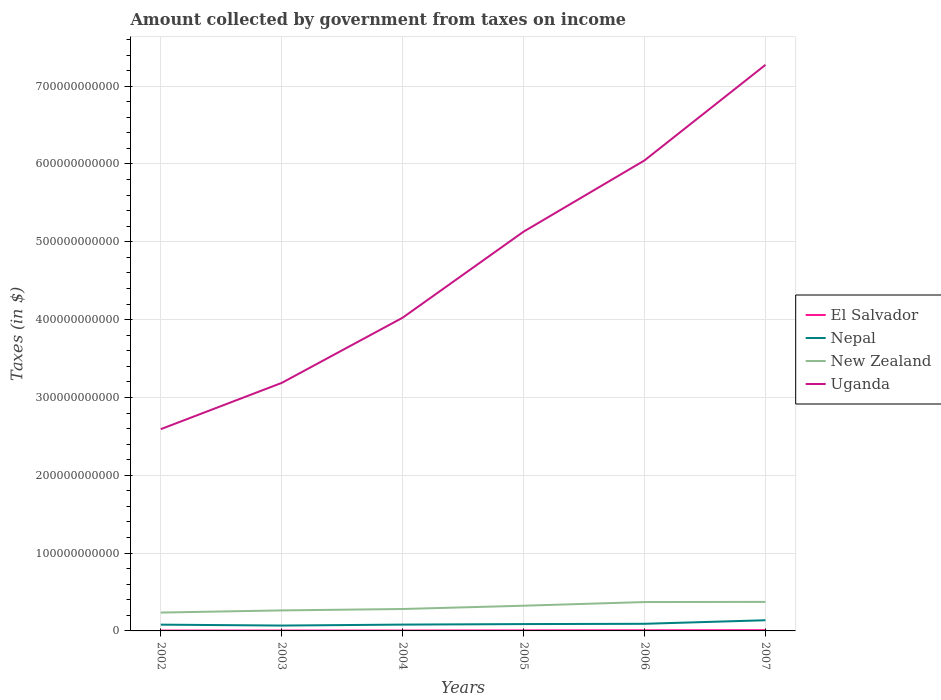Is the number of lines equal to the number of legend labels?
Offer a very short reply. Yes. Across all years, what is the maximum amount collected by government from taxes on income in Uganda?
Make the answer very short. 2.59e+11. In which year was the amount collected by government from taxes on income in Nepal maximum?
Offer a very short reply. 2003. What is the total amount collected by government from taxes on income in New Zealand in the graph?
Give a very brief answer. -9.16e+09. What is the difference between the highest and the second highest amount collected by government from taxes on income in El Salvador?
Ensure brevity in your answer.  4.94e+08. What is the difference between two consecutive major ticks on the Y-axis?
Give a very brief answer. 1.00e+11. Does the graph contain any zero values?
Offer a terse response. No. Where does the legend appear in the graph?
Offer a very short reply. Center right. What is the title of the graph?
Offer a terse response. Amount collected by government from taxes on income. Does "Papua New Guinea" appear as one of the legend labels in the graph?
Make the answer very short. No. What is the label or title of the X-axis?
Give a very brief answer. Years. What is the label or title of the Y-axis?
Your answer should be very brief. Taxes (in $). What is the Taxes (in $) in El Salvador in 2002?
Give a very brief answer. 4.71e+08. What is the Taxes (in $) in Nepal in 2002?
Give a very brief answer. 8.07e+09. What is the Taxes (in $) in New Zealand in 2002?
Your answer should be very brief. 2.36e+1. What is the Taxes (in $) in Uganda in 2002?
Offer a very short reply. 2.59e+11. What is the Taxes (in $) in El Salvador in 2003?
Keep it short and to the point. 4.98e+08. What is the Taxes (in $) in Nepal in 2003?
Offer a very short reply. 6.88e+09. What is the Taxes (in $) in New Zealand in 2003?
Offer a very short reply. 2.64e+1. What is the Taxes (in $) in Uganda in 2003?
Give a very brief answer. 3.19e+11. What is the Taxes (in $) of El Salvador in 2004?
Provide a short and direct response. 5.25e+08. What is the Taxes (in $) of Nepal in 2004?
Make the answer very short. 8.12e+09. What is the Taxes (in $) of New Zealand in 2004?
Provide a succinct answer. 2.82e+1. What is the Taxes (in $) of Uganda in 2004?
Offer a very short reply. 4.02e+11. What is the Taxes (in $) of El Salvador in 2005?
Your answer should be very brief. 6.63e+08. What is the Taxes (in $) in Nepal in 2005?
Your answer should be very brief. 8.79e+09. What is the Taxes (in $) of New Zealand in 2005?
Ensure brevity in your answer.  3.24e+1. What is the Taxes (in $) in Uganda in 2005?
Offer a terse response. 5.13e+11. What is the Taxes (in $) of El Salvador in 2006?
Your answer should be very brief. 8.16e+08. What is the Taxes (in $) in Nepal in 2006?
Make the answer very short. 9.16e+09. What is the Taxes (in $) of New Zealand in 2006?
Provide a short and direct response. 3.71e+1. What is the Taxes (in $) in Uganda in 2006?
Provide a succinct answer. 6.05e+11. What is the Taxes (in $) in El Salvador in 2007?
Your answer should be very brief. 9.65e+08. What is the Taxes (in $) in Nepal in 2007?
Your answer should be very brief. 1.37e+1. What is the Taxes (in $) of New Zealand in 2007?
Your answer should be very brief. 3.73e+1. What is the Taxes (in $) in Uganda in 2007?
Keep it short and to the point. 7.27e+11. Across all years, what is the maximum Taxes (in $) of El Salvador?
Offer a terse response. 9.65e+08. Across all years, what is the maximum Taxes (in $) in Nepal?
Give a very brief answer. 1.37e+1. Across all years, what is the maximum Taxes (in $) of New Zealand?
Provide a short and direct response. 3.73e+1. Across all years, what is the maximum Taxes (in $) in Uganda?
Provide a succinct answer. 7.27e+11. Across all years, what is the minimum Taxes (in $) of El Salvador?
Ensure brevity in your answer.  4.71e+08. Across all years, what is the minimum Taxes (in $) in Nepal?
Provide a succinct answer. 6.88e+09. Across all years, what is the minimum Taxes (in $) of New Zealand?
Keep it short and to the point. 2.36e+1. Across all years, what is the minimum Taxes (in $) in Uganda?
Ensure brevity in your answer.  2.59e+11. What is the total Taxes (in $) of El Salvador in the graph?
Your response must be concise. 3.94e+09. What is the total Taxes (in $) of Nepal in the graph?
Offer a terse response. 5.47e+1. What is the total Taxes (in $) of New Zealand in the graph?
Offer a very short reply. 1.85e+11. What is the total Taxes (in $) of Uganda in the graph?
Make the answer very short. 2.83e+12. What is the difference between the Taxes (in $) in El Salvador in 2002 and that in 2003?
Your answer should be very brief. -2.67e+07. What is the difference between the Taxes (in $) of Nepal in 2002 and that in 2003?
Ensure brevity in your answer.  1.19e+09. What is the difference between the Taxes (in $) of New Zealand in 2002 and that in 2003?
Offer a terse response. -2.76e+09. What is the difference between the Taxes (in $) in Uganda in 2002 and that in 2003?
Offer a very short reply. -5.94e+1. What is the difference between the Taxes (in $) of El Salvador in 2002 and that in 2004?
Your answer should be very brief. -5.35e+07. What is the difference between the Taxes (in $) of Nepal in 2002 and that in 2004?
Give a very brief answer. -5.53e+07. What is the difference between the Taxes (in $) in New Zealand in 2002 and that in 2004?
Give a very brief answer. -4.56e+09. What is the difference between the Taxes (in $) of Uganda in 2002 and that in 2004?
Your answer should be very brief. -1.43e+11. What is the difference between the Taxes (in $) in El Salvador in 2002 and that in 2005?
Keep it short and to the point. -1.91e+08. What is the difference between the Taxes (in $) in Nepal in 2002 and that in 2005?
Your answer should be compact. -7.22e+08. What is the difference between the Taxes (in $) in New Zealand in 2002 and that in 2005?
Your answer should be compact. -8.78e+09. What is the difference between the Taxes (in $) in Uganda in 2002 and that in 2005?
Your answer should be compact. -2.54e+11. What is the difference between the Taxes (in $) of El Salvador in 2002 and that in 2006?
Offer a terse response. -3.44e+08. What is the difference between the Taxes (in $) in Nepal in 2002 and that in 2006?
Provide a short and direct response. -1.09e+09. What is the difference between the Taxes (in $) of New Zealand in 2002 and that in 2006?
Ensure brevity in your answer.  -1.35e+1. What is the difference between the Taxes (in $) in Uganda in 2002 and that in 2006?
Keep it short and to the point. -3.45e+11. What is the difference between the Taxes (in $) of El Salvador in 2002 and that in 2007?
Provide a short and direct response. -4.94e+08. What is the difference between the Taxes (in $) in Nepal in 2002 and that in 2007?
Offer a terse response. -5.66e+09. What is the difference between the Taxes (in $) of New Zealand in 2002 and that in 2007?
Ensure brevity in your answer.  -1.37e+1. What is the difference between the Taxes (in $) in Uganda in 2002 and that in 2007?
Make the answer very short. -4.68e+11. What is the difference between the Taxes (in $) of El Salvador in 2003 and that in 2004?
Your answer should be compact. -2.68e+07. What is the difference between the Taxes (in $) of Nepal in 2003 and that in 2004?
Make the answer very short. -1.24e+09. What is the difference between the Taxes (in $) in New Zealand in 2003 and that in 2004?
Provide a succinct answer. -1.80e+09. What is the difference between the Taxes (in $) of Uganda in 2003 and that in 2004?
Ensure brevity in your answer.  -8.38e+1. What is the difference between the Taxes (in $) of El Salvador in 2003 and that in 2005?
Your answer should be very brief. -1.65e+08. What is the difference between the Taxes (in $) in Nepal in 2003 and that in 2005?
Your answer should be very brief. -1.91e+09. What is the difference between the Taxes (in $) of New Zealand in 2003 and that in 2005?
Offer a very short reply. -6.02e+09. What is the difference between the Taxes (in $) in Uganda in 2003 and that in 2005?
Keep it short and to the point. -1.94e+11. What is the difference between the Taxes (in $) of El Salvador in 2003 and that in 2006?
Keep it short and to the point. -3.18e+08. What is the difference between the Taxes (in $) in Nepal in 2003 and that in 2006?
Provide a succinct answer. -2.28e+09. What is the difference between the Taxes (in $) of New Zealand in 2003 and that in 2006?
Ensure brevity in your answer.  -1.07e+1. What is the difference between the Taxes (in $) of Uganda in 2003 and that in 2006?
Provide a short and direct response. -2.86e+11. What is the difference between the Taxes (in $) of El Salvador in 2003 and that in 2007?
Offer a very short reply. -4.67e+08. What is the difference between the Taxes (in $) of Nepal in 2003 and that in 2007?
Offer a terse response. -6.84e+09. What is the difference between the Taxes (in $) in New Zealand in 2003 and that in 2007?
Keep it short and to the point. -1.10e+1. What is the difference between the Taxes (in $) in Uganda in 2003 and that in 2007?
Make the answer very short. -4.09e+11. What is the difference between the Taxes (in $) of El Salvador in 2004 and that in 2005?
Ensure brevity in your answer.  -1.38e+08. What is the difference between the Taxes (in $) of Nepal in 2004 and that in 2005?
Your answer should be compact. -6.67e+08. What is the difference between the Taxes (in $) of New Zealand in 2004 and that in 2005?
Provide a succinct answer. -4.22e+09. What is the difference between the Taxes (in $) of Uganda in 2004 and that in 2005?
Give a very brief answer. -1.11e+11. What is the difference between the Taxes (in $) of El Salvador in 2004 and that in 2006?
Keep it short and to the point. -2.91e+08. What is the difference between the Taxes (in $) in Nepal in 2004 and that in 2006?
Make the answer very short. -1.04e+09. What is the difference between the Taxes (in $) of New Zealand in 2004 and that in 2006?
Your answer should be very brief. -8.94e+09. What is the difference between the Taxes (in $) of Uganda in 2004 and that in 2006?
Your response must be concise. -2.02e+11. What is the difference between the Taxes (in $) in El Salvador in 2004 and that in 2007?
Make the answer very short. -4.40e+08. What is the difference between the Taxes (in $) of Nepal in 2004 and that in 2007?
Make the answer very short. -5.60e+09. What is the difference between the Taxes (in $) of New Zealand in 2004 and that in 2007?
Offer a very short reply. -9.16e+09. What is the difference between the Taxes (in $) of Uganda in 2004 and that in 2007?
Keep it short and to the point. -3.25e+11. What is the difference between the Taxes (in $) of El Salvador in 2005 and that in 2006?
Your response must be concise. -1.53e+08. What is the difference between the Taxes (in $) of Nepal in 2005 and that in 2006?
Keep it short and to the point. -3.72e+08. What is the difference between the Taxes (in $) of New Zealand in 2005 and that in 2006?
Your response must be concise. -4.72e+09. What is the difference between the Taxes (in $) in Uganda in 2005 and that in 2006?
Your answer should be very brief. -9.16e+1. What is the difference between the Taxes (in $) of El Salvador in 2005 and that in 2007?
Your answer should be compact. -3.02e+08. What is the difference between the Taxes (in $) of Nepal in 2005 and that in 2007?
Your response must be concise. -4.93e+09. What is the difference between the Taxes (in $) of New Zealand in 2005 and that in 2007?
Give a very brief answer. -4.94e+09. What is the difference between the Taxes (in $) in Uganda in 2005 and that in 2007?
Ensure brevity in your answer.  -2.14e+11. What is the difference between the Taxes (in $) in El Salvador in 2006 and that in 2007?
Keep it short and to the point. -1.49e+08. What is the difference between the Taxes (in $) in Nepal in 2006 and that in 2007?
Offer a terse response. -4.56e+09. What is the difference between the Taxes (in $) in New Zealand in 2006 and that in 2007?
Keep it short and to the point. -2.25e+08. What is the difference between the Taxes (in $) of Uganda in 2006 and that in 2007?
Your response must be concise. -1.23e+11. What is the difference between the Taxes (in $) of El Salvador in 2002 and the Taxes (in $) of Nepal in 2003?
Keep it short and to the point. -6.41e+09. What is the difference between the Taxes (in $) in El Salvador in 2002 and the Taxes (in $) in New Zealand in 2003?
Provide a short and direct response. -2.59e+1. What is the difference between the Taxes (in $) in El Salvador in 2002 and the Taxes (in $) in Uganda in 2003?
Provide a short and direct response. -3.18e+11. What is the difference between the Taxes (in $) in Nepal in 2002 and the Taxes (in $) in New Zealand in 2003?
Your answer should be compact. -1.83e+1. What is the difference between the Taxes (in $) in Nepal in 2002 and the Taxes (in $) in Uganda in 2003?
Give a very brief answer. -3.11e+11. What is the difference between the Taxes (in $) of New Zealand in 2002 and the Taxes (in $) of Uganda in 2003?
Offer a terse response. -2.95e+11. What is the difference between the Taxes (in $) in El Salvador in 2002 and the Taxes (in $) in Nepal in 2004?
Offer a very short reply. -7.65e+09. What is the difference between the Taxes (in $) of El Salvador in 2002 and the Taxes (in $) of New Zealand in 2004?
Offer a terse response. -2.77e+1. What is the difference between the Taxes (in $) in El Salvador in 2002 and the Taxes (in $) in Uganda in 2004?
Keep it short and to the point. -4.02e+11. What is the difference between the Taxes (in $) in Nepal in 2002 and the Taxes (in $) in New Zealand in 2004?
Provide a short and direct response. -2.01e+1. What is the difference between the Taxes (in $) of Nepal in 2002 and the Taxes (in $) of Uganda in 2004?
Offer a very short reply. -3.94e+11. What is the difference between the Taxes (in $) in New Zealand in 2002 and the Taxes (in $) in Uganda in 2004?
Your answer should be very brief. -3.79e+11. What is the difference between the Taxes (in $) of El Salvador in 2002 and the Taxes (in $) of Nepal in 2005?
Your answer should be very brief. -8.32e+09. What is the difference between the Taxes (in $) in El Salvador in 2002 and the Taxes (in $) in New Zealand in 2005?
Ensure brevity in your answer.  -3.19e+1. What is the difference between the Taxes (in $) in El Salvador in 2002 and the Taxes (in $) in Uganda in 2005?
Keep it short and to the point. -5.13e+11. What is the difference between the Taxes (in $) of Nepal in 2002 and the Taxes (in $) of New Zealand in 2005?
Your response must be concise. -2.43e+1. What is the difference between the Taxes (in $) in Nepal in 2002 and the Taxes (in $) in Uganda in 2005?
Ensure brevity in your answer.  -5.05e+11. What is the difference between the Taxes (in $) of New Zealand in 2002 and the Taxes (in $) of Uganda in 2005?
Your response must be concise. -4.89e+11. What is the difference between the Taxes (in $) of El Salvador in 2002 and the Taxes (in $) of Nepal in 2006?
Your response must be concise. -8.69e+09. What is the difference between the Taxes (in $) in El Salvador in 2002 and the Taxes (in $) in New Zealand in 2006?
Keep it short and to the point. -3.66e+1. What is the difference between the Taxes (in $) of El Salvador in 2002 and the Taxes (in $) of Uganda in 2006?
Your answer should be compact. -6.04e+11. What is the difference between the Taxes (in $) in Nepal in 2002 and the Taxes (in $) in New Zealand in 2006?
Your response must be concise. -2.90e+1. What is the difference between the Taxes (in $) of Nepal in 2002 and the Taxes (in $) of Uganda in 2006?
Offer a very short reply. -5.97e+11. What is the difference between the Taxes (in $) of New Zealand in 2002 and the Taxes (in $) of Uganda in 2006?
Provide a succinct answer. -5.81e+11. What is the difference between the Taxes (in $) in El Salvador in 2002 and the Taxes (in $) in Nepal in 2007?
Ensure brevity in your answer.  -1.33e+1. What is the difference between the Taxes (in $) of El Salvador in 2002 and the Taxes (in $) of New Zealand in 2007?
Your answer should be very brief. -3.68e+1. What is the difference between the Taxes (in $) of El Salvador in 2002 and the Taxes (in $) of Uganda in 2007?
Keep it short and to the point. -7.27e+11. What is the difference between the Taxes (in $) of Nepal in 2002 and the Taxes (in $) of New Zealand in 2007?
Provide a succinct answer. -2.93e+1. What is the difference between the Taxes (in $) in Nepal in 2002 and the Taxes (in $) in Uganda in 2007?
Your answer should be compact. -7.19e+11. What is the difference between the Taxes (in $) in New Zealand in 2002 and the Taxes (in $) in Uganda in 2007?
Your answer should be very brief. -7.04e+11. What is the difference between the Taxes (in $) in El Salvador in 2003 and the Taxes (in $) in Nepal in 2004?
Give a very brief answer. -7.63e+09. What is the difference between the Taxes (in $) of El Salvador in 2003 and the Taxes (in $) of New Zealand in 2004?
Provide a short and direct response. -2.77e+1. What is the difference between the Taxes (in $) in El Salvador in 2003 and the Taxes (in $) in Uganda in 2004?
Offer a terse response. -4.02e+11. What is the difference between the Taxes (in $) in Nepal in 2003 and the Taxes (in $) in New Zealand in 2004?
Offer a very short reply. -2.13e+1. What is the difference between the Taxes (in $) in Nepal in 2003 and the Taxes (in $) in Uganda in 2004?
Your answer should be very brief. -3.96e+11. What is the difference between the Taxes (in $) in New Zealand in 2003 and the Taxes (in $) in Uganda in 2004?
Your answer should be compact. -3.76e+11. What is the difference between the Taxes (in $) in El Salvador in 2003 and the Taxes (in $) in Nepal in 2005?
Make the answer very short. -8.29e+09. What is the difference between the Taxes (in $) in El Salvador in 2003 and the Taxes (in $) in New Zealand in 2005?
Ensure brevity in your answer.  -3.19e+1. What is the difference between the Taxes (in $) in El Salvador in 2003 and the Taxes (in $) in Uganda in 2005?
Provide a succinct answer. -5.13e+11. What is the difference between the Taxes (in $) in Nepal in 2003 and the Taxes (in $) in New Zealand in 2005?
Ensure brevity in your answer.  -2.55e+1. What is the difference between the Taxes (in $) in Nepal in 2003 and the Taxes (in $) in Uganda in 2005?
Your response must be concise. -5.06e+11. What is the difference between the Taxes (in $) in New Zealand in 2003 and the Taxes (in $) in Uganda in 2005?
Give a very brief answer. -4.87e+11. What is the difference between the Taxes (in $) in El Salvador in 2003 and the Taxes (in $) in Nepal in 2006?
Offer a very short reply. -8.66e+09. What is the difference between the Taxes (in $) of El Salvador in 2003 and the Taxes (in $) of New Zealand in 2006?
Your response must be concise. -3.66e+1. What is the difference between the Taxes (in $) of El Salvador in 2003 and the Taxes (in $) of Uganda in 2006?
Offer a very short reply. -6.04e+11. What is the difference between the Taxes (in $) in Nepal in 2003 and the Taxes (in $) in New Zealand in 2006?
Offer a terse response. -3.02e+1. What is the difference between the Taxes (in $) in Nepal in 2003 and the Taxes (in $) in Uganda in 2006?
Provide a succinct answer. -5.98e+11. What is the difference between the Taxes (in $) in New Zealand in 2003 and the Taxes (in $) in Uganda in 2006?
Offer a terse response. -5.78e+11. What is the difference between the Taxes (in $) of El Salvador in 2003 and the Taxes (in $) of Nepal in 2007?
Your answer should be very brief. -1.32e+1. What is the difference between the Taxes (in $) in El Salvador in 2003 and the Taxes (in $) in New Zealand in 2007?
Provide a short and direct response. -3.68e+1. What is the difference between the Taxes (in $) in El Salvador in 2003 and the Taxes (in $) in Uganda in 2007?
Your answer should be compact. -7.27e+11. What is the difference between the Taxes (in $) in Nepal in 2003 and the Taxes (in $) in New Zealand in 2007?
Offer a very short reply. -3.04e+1. What is the difference between the Taxes (in $) in Nepal in 2003 and the Taxes (in $) in Uganda in 2007?
Offer a terse response. -7.21e+11. What is the difference between the Taxes (in $) of New Zealand in 2003 and the Taxes (in $) of Uganda in 2007?
Give a very brief answer. -7.01e+11. What is the difference between the Taxes (in $) in El Salvador in 2004 and the Taxes (in $) in Nepal in 2005?
Make the answer very short. -8.27e+09. What is the difference between the Taxes (in $) of El Salvador in 2004 and the Taxes (in $) of New Zealand in 2005?
Ensure brevity in your answer.  -3.19e+1. What is the difference between the Taxes (in $) in El Salvador in 2004 and the Taxes (in $) in Uganda in 2005?
Give a very brief answer. -5.13e+11. What is the difference between the Taxes (in $) of Nepal in 2004 and the Taxes (in $) of New Zealand in 2005?
Keep it short and to the point. -2.43e+1. What is the difference between the Taxes (in $) in Nepal in 2004 and the Taxes (in $) in Uganda in 2005?
Your answer should be compact. -5.05e+11. What is the difference between the Taxes (in $) of New Zealand in 2004 and the Taxes (in $) of Uganda in 2005?
Give a very brief answer. -4.85e+11. What is the difference between the Taxes (in $) of El Salvador in 2004 and the Taxes (in $) of Nepal in 2006?
Make the answer very short. -8.64e+09. What is the difference between the Taxes (in $) of El Salvador in 2004 and the Taxes (in $) of New Zealand in 2006?
Provide a short and direct response. -3.66e+1. What is the difference between the Taxes (in $) in El Salvador in 2004 and the Taxes (in $) in Uganda in 2006?
Your response must be concise. -6.04e+11. What is the difference between the Taxes (in $) of Nepal in 2004 and the Taxes (in $) of New Zealand in 2006?
Your answer should be very brief. -2.90e+1. What is the difference between the Taxes (in $) in Nepal in 2004 and the Taxes (in $) in Uganda in 2006?
Your response must be concise. -5.96e+11. What is the difference between the Taxes (in $) of New Zealand in 2004 and the Taxes (in $) of Uganda in 2006?
Offer a very short reply. -5.76e+11. What is the difference between the Taxes (in $) in El Salvador in 2004 and the Taxes (in $) in Nepal in 2007?
Your response must be concise. -1.32e+1. What is the difference between the Taxes (in $) of El Salvador in 2004 and the Taxes (in $) of New Zealand in 2007?
Offer a terse response. -3.68e+1. What is the difference between the Taxes (in $) in El Salvador in 2004 and the Taxes (in $) in Uganda in 2007?
Your answer should be compact. -7.27e+11. What is the difference between the Taxes (in $) of Nepal in 2004 and the Taxes (in $) of New Zealand in 2007?
Your response must be concise. -2.92e+1. What is the difference between the Taxes (in $) in Nepal in 2004 and the Taxes (in $) in Uganda in 2007?
Provide a succinct answer. -7.19e+11. What is the difference between the Taxes (in $) in New Zealand in 2004 and the Taxes (in $) in Uganda in 2007?
Provide a succinct answer. -6.99e+11. What is the difference between the Taxes (in $) of El Salvador in 2005 and the Taxes (in $) of Nepal in 2006?
Keep it short and to the point. -8.50e+09. What is the difference between the Taxes (in $) of El Salvador in 2005 and the Taxes (in $) of New Zealand in 2006?
Keep it short and to the point. -3.64e+1. What is the difference between the Taxes (in $) of El Salvador in 2005 and the Taxes (in $) of Uganda in 2006?
Provide a short and direct response. -6.04e+11. What is the difference between the Taxes (in $) in Nepal in 2005 and the Taxes (in $) in New Zealand in 2006?
Ensure brevity in your answer.  -2.83e+1. What is the difference between the Taxes (in $) of Nepal in 2005 and the Taxes (in $) of Uganda in 2006?
Make the answer very short. -5.96e+11. What is the difference between the Taxes (in $) in New Zealand in 2005 and the Taxes (in $) in Uganda in 2006?
Offer a very short reply. -5.72e+11. What is the difference between the Taxes (in $) in El Salvador in 2005 and the Taxes (in $) in Nepal in 2007?
Provide a succinct answer. -1.31e+1. What is the difference between the Taxes (in $) in El Salvador in 2005 and the Taxes (in $) in New Zealand in 2007?
Provide a short and direct response. -3.67e+1. What is the difference between the Taxes (in $) of El Salvador in 2005 and the Taxes (in $) of Uganda in 2007?
Ensure brevity in your answer.  -7.27e+11. What is the difference between the Taxes (in $) in Nepal in 2005 and the Taxes (in $) in New Zealand in 2007?
Keep it short and to the point. -2.85e+1. What is the difference between the Taxes (in $) of Nepal in 2005 and the Taxes (in $) of Uganda in 2007?
Give a very brief answer. -7.19e+11. What is the difference between the Taxes (in $) in New Zealand in 2005 and the Taxes (in $) in Uganda in 2007?
Provide a short and direct response. -6.95e+11. What is the difference between the Taxes (in $) of El Salvador in 2006 and the Taxes (in $) of Nepal in 2007?
Your answer should be compact. -1.29e+1. What is the difference between the Taxes (in $) of El Salvador in 2006 and the Taxes (in $) of New Zealand in 2007?
Ensure brevity in your answer.  -3.65e+1. What is the difference between the Taxes (in $) of El Salvador in 2006 and the Taxes (in $) of Uganda in 2007?
Offer a very short reply. -7.27e+11. What is the difference between the Taxes (in $) in Nepal in 2006 and the Taxes (in $) in New Zealand in 2007?
Make the answer very short. -2.82e+1. What is the difference between the Taxes (in $) in Nepal in 2006 and the Taxes (in $) in Uganda in 2007?
Keep it short and to the point. -7.18e+11. What is the difference between the Taxes (in $) in New Zealand in 2006 and the Taxes (in $) in Uganda in 2007?
Make the answer very short. -6.90e+11. What is the average Taxes (in $) in El Salvador per year?
Your response must be concise. 6.56e+08. What is the average Taxes (in $) of Nepal per year?
Ensure brevity in your answer.  9.12e+09. What is the average Taxes (in $) of New Zealand per year?
Keep it short and to the point. 3.08e+1. What is the average Taxes (in $) in Uganda per year?
Provide a succinct answer. 4.71e+11. In the year 2002, what is the difference between the Taxes (in $) of El Salvador and Taxes (in $) of Nepal?
Offer a terse response. -7.60e+09. In the year 2002, what is the difference between the Taxes (in $) in El Salvador and Taxes (in $) in New Zealand?
Make the answer very short. -2.31e+1. In the year 2002, what is the difference between the Taxes (in $) of El Salvador and Taxes (in $) of Uganda?
Provide a short and direct response. -2.59e+11. In the year 2002, what is the difference between the Taxes (in $) in Nepal and Taxes (in $) in New Zealand?
Provide a short and direct response. -1.55e+1. In the year 2002, what is the difference between the Taxes (in $) of Nepal and Taxes (in $) of Uganda?
Your response must be concise. -2.51e+11. In the year 2002, what is the difference between the Taxes (in $) in New Zealand and Taxes (in $) in Uganda?
Your answer should be compact. -2.36e+11. In the year 2003, what is the difference between the Taxes (in $) in El Salvador and Taxes (in $) in Nepal?
Provide a succinct answer. -6.38e+09. In the year 2003, what is the difference between the Taxes (in $) of El Salvador and Taxes (in $) of New Zealand?
Offer a terse response. -2.59e+1. In the year 2003, what is the difference between the Taxes (in $) in El Salvador and Taxes (in $) in Uganda?
Offer a terse response. -3.18e+11. In the year 2003, what is the difference between the Taxes (in $) of Nepal and Taxes (in $) of New Zealand?
Ensure brevity in your answer.  -1.95e+1. In the year 2003, what is the difference between the Taxes (in $) in Nepal and Taxes (in $) in Uganda?
Keep it short and to the point. -3.12e+11. In the year 2003, what is the difference between the Taxes (in $) in New Zealand and Taxes (in $) in Uganda?
Offer a very short reply. -2.92e+11. In the year 2004, what is the difference between the Taxes (in $) in El Salvador and Taxes (in $) in Nepal?
Your response must be concise. -7.60e+09. In the year 2004, what is the difference between the Taxes (in $) in El Salvador and Taxes (in $) in New Zealand?
Provide a short and direct response. -2.76e+1. In the year 2004, what is the difference between the Taxes (in $) in El Salvador and Taxes (in $) in Uganda?
Ensure brevity in your answer.  -4.02e+11. In the year 2004, what is the difference between the Taxes (in $) in Nepal and Taxes (in $) in New Zealand?
Your answer should be very brief. -2.00e+1. In the year 2004, what is the difference between the Taxes (in $) of Nepal and Taxes (in $) of Uganda?
Provide a succinct answer. -3.94e+11. In the year 2004, what is the difference between the Taxes (in $) in New Zealand and Taxes (in $) in Uganda?
Offer a very short reply. -3.74e+11. In the year 2005, what is the difference between the Taxes (in $) in El Salvador and Taxes (in $) in Nepal?
Provide a succinct answer. -8.13e+09. In the year 2005, what is the difference between the Taxes (in $) of El Salvador and Taxes (in $) of New Zealand?
Make the answer very short. -3.17e+1. In the year 2005, what is the difference between the Taxes (in $) in El Salvador and Taxes (in $) in Uganda?
Ensure brevity in your answer.  -5.12e+11. In the year 2005, what is the difference between the Taxes (in $) of Nepal and Taxes (in $) of New Zealand?
Ensure brevity in your answer.  -2.36e+1. In the year 2005, what is the difference between the Taxes (in $) in Nepal and Taxes (in $) in Uganda?
Your response must be concise. -5.04e+11. In the year 2005, what is the difference between the Taxes (in $) of New Zealand and Taxes (in $) of Uganda?
Keep it short and to the point. -4.81e+11. In the year 2006, what is the difference between the Taxes (in $) of El Salvador and Taxes (in $) of Nepal?
Your answer should be very brief. -8.35e+09. In the year 2006, what is the difference between the Taxes (in $) of El Salvador and Taxes (in $) of New Zealand?
Give a very brief answer. -3.63e+1. In the year 2006, what is the difference between the Taxes (in $) of El Salvador and Taxes (in $) of Uganda?
Offer a very short reply. -6.04e+11. In the year 2006, what is the difference between the Taxes (in $) of Nepal and Taxes (in $) of New Zealand?
Give a very brief answer. -2.79e+1. In the year 2006, what is the difference between the Taxes (in $) in Nepal and Taxes (in $) in Uganda?
Give a very brief answer. -5.95e+11. In the year 2006, what is the difference between the Taxes (in $) of New Zealand and Taxes (in $) of Uganda?
Provide a short and direct response. -5.68e+11. In the year 2007, what is the difference between the Taxes (in $) of El Salvador and Taxes (in $) of Nepal?
Give a very brief answer. -1.28e+1. In the year 2007, what is the difference between the Taxes (in $) in El Salvador and Taxes (in $) in New Zealand?
Offer a very short reply. -3.64e+1. In the year 2007, what is the difference between the Taxes (in $) of El Salvador and Taxes (in $) of Uganda?
Make the answer very short. -7.26e+11. In the year 2007, what is the difference between the Taxes (in $) of Nepal and Taxes (in $) of New Zealand?
Your response must be concise. -2.36e+1. In the year 2007, what is the difference between the Taxes (in $) in Nepal and Taxes (in $) in Uganda?
Offer a very short reply. -7.14e+11. In the year 2007, what is the difference between the Taxes (in $) in New Zealand and Taxes (in $) in Uganda?
Offer a very short reply. -6.90e+11. What is the ratio of the Taxes (in $) in El Salvador in 2002 to that in 2003?
Provide a short and direct response. 0.95. What is the ratio of the Taxes (in $) of Nepal in 2002 to that in 2003?
Make the answer very short. 1.17. What is the ratio of the Taxes (in $) in New Zealand in 2002 to that in 2003?
Your response must be concise. 0.9. What is the ratio of the Taxes (in $) in Uganda in 2002 to that in 2003?
Your answer should be very brief. 0.81. What is the ratio of the Taxes (in $) in El Salvador in 2002 to that in 2004?
Offer a terse response. 0.9. What is the ratio of the Taxes (in $) of New Zealand in 2002 to that in 2004?
Give a very brief answer. 0.84. What is the ratio of the Taxes (in $) in Uganda in 2002 to that in 2004?
Give a very brief answer. 0.64. What is the ratio of the Taxes (in $) of El Salvador in 2002 to that in 2005?
Your answer should be compact. 0.71. What is the ratio of the Taxes (in $) of Nepal in 2002 to that in 2005?
Your answer should be compact. 0.92. What is the ratio of the Taxes (in $) in New Zealand in 2002 to that in 2005?
Give a very brief answer. 0.73. What is the ratio of the Taxes (in $) of Uganda in 2002 to that in 2005?
Your response must be concise. 0.51. What is the ratio of the Taxes (in $) in El Salvador in 2002 to that in 2006?
Offer a terse response. 0.58. What is the ratio of the Taxes (in $) in Nepal in 2002 to that in 2006?
Ensure brevity in your answer.  0.88. What is the ratio of the Taxes (in $) of New Zealand in 2002 to that in 2006?
Your response must be concise. 0.64. What is the ratio of the Taxes (in $) of Uganda in 2002 to that in 2006?
Your answer should be compact. 0.43. What is the ratio of the Taxes (in $) in El Salvador in 2002 to that in 2007?
Provide a succinct answer. 0.49. What is the ratio of the Taxes (in $) in Nepal in 2002 to that in 2007?
Make the answer very short. 0.59. What is the ratio of the Taxes (in $) in New Zealand in 2002 to that in 2007?
Offer a terse response. 0.63. What is the ratio of the Taxes (in $) of Uganda in 2002 to that in 2007?
Ensure brevity in your answer.  0.36. What is the ratio of the Taxes (in $) in El Salvador in 2003 to that in 2004?
Offer a terse response. 0.95. What is the ratio of the Taxes (in $) of Nepal in 2003 to that in 2004?
Your answer should be very brief. 0.85. What is the ratio of the Taxes (in $) of New Zealand in 2003 to that in 2004?
Ensure brevity in your answer.  0.94. What is the ratio of the Taxes (in $) in Uganda in 2003 to that in 2004?
Keep it short and to the point. 0.79. What is the ratio of the Taxes (in $) in El Salvador in 2003 to that in 2005?
Your answer should be very brief. 0.75. What is the ratio of the Taxes (in $) of Nepal in 2003 to that in 2005?
Provide a succinct answer. 0.78. What is the ratio of the Taxes (in $) of New Zealand in 2003 to that in 2005?
Provide a short and direct response. 0.81. What is the ratio of the Taxes (in $) in Uganda in 2003 to that in 2005?
Provide a short and direct response. 0.62. What is the ratio of the Taxes (in $) in El Salvador in 2003 to that in 2006?
Provide a succinct answer. 0.61. What is the ratio of the Taxes (in $) in Nepal in 2003 to that in 2006?
Give a very brief answer. 0.75. What is the ratio of the Taxes (in $) in New Zealand in 2003 to that in 2006?
Ensure brevity in your answer.  0.71. What is the ratio of the Taxes (in $) of Uganda in 2003 to that in 2006?
Offer a very short reply. 0.53. What is the ratio of the Taxes (in $) in El Salvador in 2003 to that in 2007?
Ensure brevity in your answer.  0.52. What is the ratio of the Taxes (in $) of Nepal in 2003 to that in 2007?
Make the answer very short. 0.5. What is the ratio of the Taxes (in $) of New Zealand in 2003 to that in 2007?
Your response must be concise. 0.71. What is the ratio of the Taxes (in $) in Uganda in 2003 to that in 2007?
Your response must be concise. 0.44. What is the ratio of the Taxes (in $) of El Salvador in 2004 to that in 2005?
Ensure brevity in your answer.  0.79. What is the ratio of the Taxes (in $) in Nepal in 2004 to that in 2005?
Your answer should be compact. 0.92. What is the ratio of the Taxes (in $) in New Zealand in 2004 to that in 2005?
Your response must be concise. 0.87. What is the ratio of the Taxes (in $) in Uganda in 2004 to that in 2005?
Ensure brevity in your answer.  0.78. What is the ratio of the Taxes (in $) in El Salvador in 2004 to that in 2006?
Offer a terse response. 0.64. What is the ratio of the Taxes (in $) of Nepal in 2004 to that in 2006?
Keep it short and to the point. 0.89. What is the ratio of the Taxes (in $) in New Zealand in 2004 to that in 2006?
Offer a very short reply. 0.76. What is the ratio of the Taxes (in $) in Uganda in 2004 to that in 2006?
Offer a terse response. 0.67. What is the ratio of the Taxes (in $) of El Salvador in 2004 to that in 2007?
Ensure brevity in your answer.  0.54. What is the ratio of the Taxes (in $) of Nepal in 2004 to that in 2007?
Offer a terse response. 0.59. What is the ratio of the Taxes (in $) of New Zealand in 2004 to that in 2007?
Your answer should be very brief. 0.75. What is the ratio of the Taxes (in $) of Uganda in 2004 to that in 2007?
Offer a terse response. 0.55. What is the ratio of the Taxes (in $) in El Salvador in 2005 to that in 2006?
Offer a very short reply. 0.81. What is the ratio of the Taxes (in $) in Nepal in 2005 to that in 2006?
Offer a very short reply. 0.96. What is the ratio of the Taxes (in $) in New Zealand in 2005 to that in 2006?
Make the answer very short. 0.87. What is the ratio of the Taxes (in $) of Uganda in 2005 to that in 2006?
Your answer should be compact. 0.85. What is the ratio of the Taxes (in $) in El Salvador in 2005 to that in 2007?
Provide a short and direct response. 0.69. What is the ratio of the Taxes (in $) of Nepal in 2005 to that in 2007?
Provide a succinct answer. 0.64. What is the ratio of the Taxes (in $) of New Zealand in 2005 to that in 2007?
Your answer should be very brief. 0.87. What is the ratio of the Taxes (in $) in Uganda in 2005 to that in 2007?
Provide a succinct answer. 0.71. What is the ratio of the Taxes (in $) in El Salvador in 2006 to that in 2007?
Give a very brief answer. 0.85. What is the ratio of the Taxes (in $) of Nepal in 2006 to that in 2007?
Provide a short and direct response. 0.67. What is the ratio of the Taxes (in $) in New Zealand in 2006 to that in 2007?
Offer a very short reply. 0.99. What is the ratio of the Taxes (in $) in Uganda in 2006 to that in 2007?
Provide a short and direct response. 0.83. What is the difference between the highest and the second highest Taxes (in $) in El Salvador?
Make the answer very short. 1.49e+08. What is the difference between the highest and the second highest Taxes (in $) in Nepal?
Give a very brief answer. 4.56e+09. What is the difference between the highest and the second highest Taxes (in $) of New Zealand?
Offer a terse response. 2.25e+08. What is the difference between the highest and the second highest Taxes (in $) in Uganda?
Provide a short and direct response. 1.23e+11. What is the difference between the highest and the lowest Taxes (in $) in El Salvador?
Ensure brevity in your answer.  4.94e+08. What is the difference between the highest and the lowest Taxes (in $) in Nepal?
Provide a short and direct response. 6.84e+09. What is the difference between the highest and the lowest Taxes (in $) of New Zealand?
Make the answer very short. 1.37e+1. What is the difference between the highest and the lowest Taxes (in $) in Uganda?
Offer a terse response. 4.68e+11. 